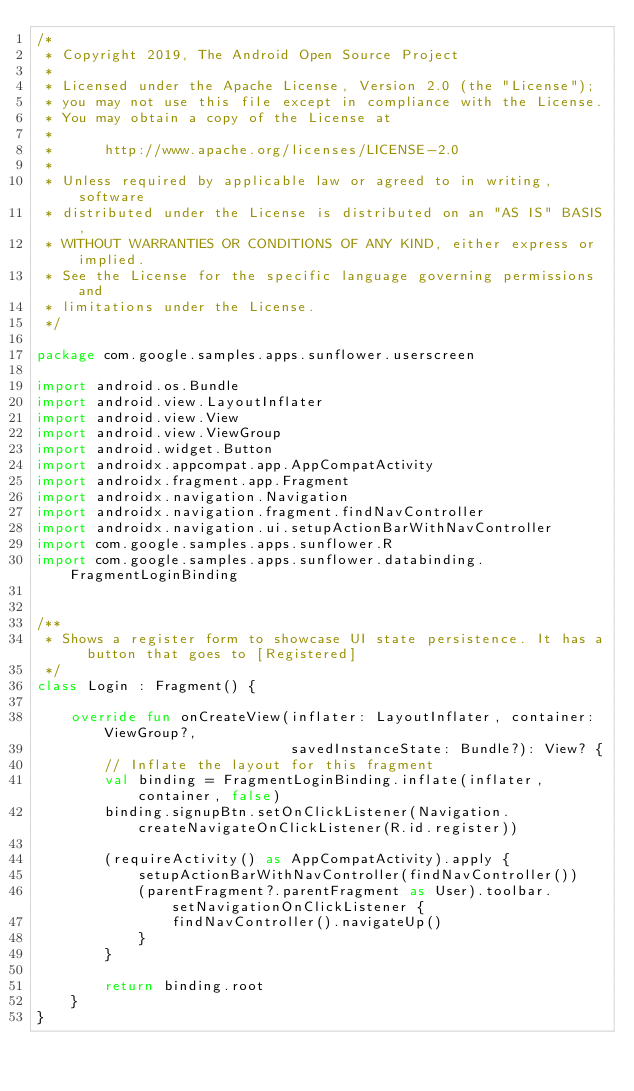Convert code to text. <code><loc_0><loc_0><loc_500><loc_500><_Kotlin_>/*
 * Copyright 2019, The Android Open Source Project
 *
 * Licensed under the Apache License, Version 2.0 (the "License");
 * you may not use this file except in compliance with the License.
 * You may obtain a copy of the License at
 *
 *      http://www.apache.org/licenses/LICENSE-2.0
 *
 * Unless required by applicable law or agreed to in writing, software
 * distributed under the License is distributed on an "AS IS" BASIS,
 * WITHOUT WARRANTIES OR CONDITIONS OF ANY KIND, either express or implied.
 * See the License for the specific language governing permissions and
 * limitations under the License.
 */

package com.google.samples.apps.sunflower.userscreen

import android.os.Bundle
import android.view.LayoutInflater
import android.view.View
import android.view.ViewGroup
import android.widget.Button
import androidx.appcompat.app.AppCompatActivity
import androidx.fragment.app.Fragment
import androidx.navigation.Navigation
import androidx.navigation.fragment.findNavController
import androidx.navigation.ui.setupActionBarWithNavController
import com.google.samples.apps.sunflower.R
import com.google.samples.apps.sunflower.databinding.FragmentLoginBinding


/**
 * Shows a register form to showcase UI state persistence. It has a button that goes to [Registered]
 */
class Login : Fragment() {

    override fun onCreateView(inflater: LayoutInflater, container: ViewGroup?,
                              savedInstanceState: Bundle?): View? {
        // Inflate the layout for this fragment
        val binding = FragmentLoginBinding.inflate(inflater, container, false)
        binding.signupBtn.setOnClickListener(Navigation.createNavigateOnClickListener(R.id.register))

        (requireActivity() as AppCompatActivity).apply {
            setupActionBarWithNavController(findNavController())
            (parentFragment?.parentFragment as User).toolbar.setNavigationOnClickListener {
                findNavController().navigateUp()
            }
        }

        return binding.root
    }
}
</code> 